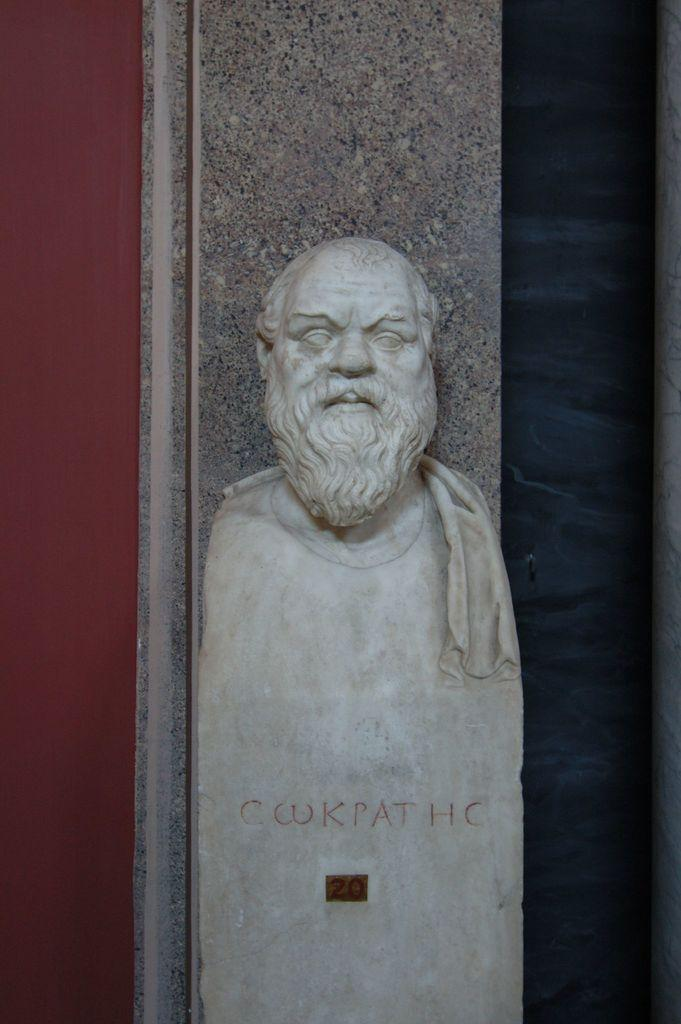What is the main subject in the foreground of the image? There is a statue in the foreground of the image. What is the statue positioned in front of? The statue is in front of a pillar. What colors are present in the background of the image? There is a blue background on the right side of the image and a red background on the left side of the image. What type of trouble does the statue cause in the image? There is no indication of any trouble caused by the statue in the image. Can you tell me how the statue wishes to be perceived in the image? The image does not convey any wishes or intentions of the statue. 